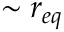<formula> <loc_0><loc_0><loc_500><loc_500>\sim r _ { e q }</formula> 